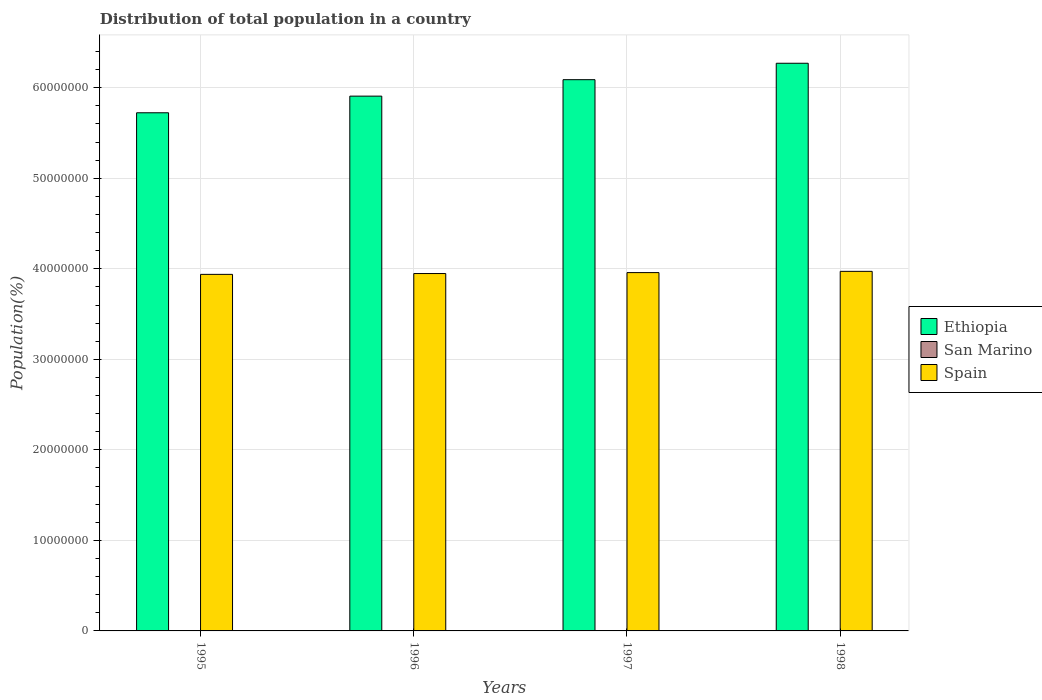How many groups of bars are there?
Your response must be concise. 4. Are the number of bars per tick equal to the number of legend labels?
Offer a very short reply. Yes. Are the number of bars on each tick of the X-axis equal?
Ensure brevity in your answer.  Yes. How many bars are there on the 2nd tick from the right?
Ensure brevity in your answer.  3. What is the label of the 1st group of bars from the left?
Your response must be concise. 1995. In how many cases, is the number of bars for a given year not equal to the number of legend labels?
Offer a terse response. 0. What is the population of in San Marino in 1995?
Provide a succinct answer. 2.59e+04. Across all years, what is the maximum population of in San Marino?
Give a very brief answer. 2.68e+04. Across all years, what is the minimum population of in Ethiopia?
Offer a very short reply. 5.72e+07. In which year was the population of in Spain maximum?
Give a very brief answer. 1998. In which year was the population of in Ethiopia minimum?
Make the answer very short. 1995. What is the total population of in Spain in the graph?
Give a very brief answer. 1.58e+08. What is the difference between the population of in Spain in 1996 and that in 1998?
Your answer should be compact. -2.43e+05. What is the difference between the population of in Spain in 1996 and the population of in San Marino in 1995?
Your answer should be very brief. 3.95e+07. What is the average population of in Spain per year?
Give a very brief answer. 3.95e+07. In the year 1996, what is the difference between the population of in Ethiopia and population of in San Marino?
Your answer should be compact. 5.91e+07. What is the ratio of the population of in San Marino in 1995 to that in 1998?
Offer a terse response. 0.97. Is the population of in Ethiopia in 1995 less than that in 1998?
Give a very brief answer. Yes. Is the difference between the population of in Ethiopia in 1996 and 1998 greater than the difference between the population of in San Marino in 1996 and 1998?
Your answer should be very brief. No. What is the difference between the highest and the second highest population of in San Marino?
Provide a short and direct response. 292. What is the difference between the highest and the lowest population of in Spain?
Your answer should be very brief. 3.34e+05. Is the sum of the population of in Ethiopia in 1995 and 1997 greater than the maximum population of in Spain across all years?
Your answer should be very brief. Yes. What does the 1st bar from the left in 1996 represents?
Give a very brief answer. Ethiopia. What does the 1st bar from the right in 1995 represents?
Provide a succinct answer. Spain. How many bars are there?
Ensure brevity in your answer.  12. What is the difference between two consecutive major ticks on the Y-axis?
Your answer should be very brief. 1.00e+07. Where does the legend appear in the graph?
Your answer should be very brief. Center right. What is the title of the graph?
Your answer should be compact. Distribution of total population in a country. Does "Djibouti" appear as one of the legend labels in the graph?
Your response must be concise. No. What is the label or title of the Y-axis?
Your answer should be very brief. Population(%). What is the Population(%) of Ethiopia in 1995?
Your answer should be compact. 5.72e+07. What is the Population(%) in San Marino in 1995?
Offer a terse response. 2.59e+04. What is the Population(%) of Spain in 1995?
Make the answer very short. 3.94e+07. What is the Population(%) in Ethiopia in 1996?
Your answer should be very brief. 5.91e+07. What is the Population(%) of San Marino in 1996?
Your answer should be very brief. 2.62e+04. What is the Population(%) of Spain in 1996?
Your answer should be very brief. 3.95e+07. What is the Population(%) in Ethiopia in 1997?
Ensure brevity in your answer.  6.09e+07. What is the Population(%) in San Marino in 1997?
Make the answer very short. 2.65e+04. What is the Population(%) of Spain in 1997?
Give a very brief answer. 3.96e+07. What is the Population(%) in Ethiopia in 1998?
Provide a short and direct response. 6.27e+07. What is the Population(%) of San Marino in 1998?
Keep it short and to the point. 2.68e+04. What is the Population(%) of Spain in 1998?
Keep it short and to the point. 3.97e+07. Across all years, what is the maximum Population(%) of Ethiopia?
Your answer should be compact. 6.27e+07. Across all years, what is the maximum Population(%) in San Marino?
Your answer should be very brief. 2.68e+04. Across all years, what is the maximum Population(%) in Spain?
Keep it short and to the point. 3.97e+07. Across all years, what is the minimum Population(%) of Ethiopia?
Provide a short and direct response. 5.72e+07. Across all years, what is the minimum Population(%) of San Marino?
Provide a short and direct response. 2.59e+04. Across all years, what is the minimum Population(%) in Spain?
Give a very brief answer. 3.94e+07. What is the total Population(%) of Ethiopia in the graph?
Provide a succinct answer. 2.40e+08. What is the total Population(%) in San Marino in the graph?
Give a very brief answer. 1.05e+05. What is the total Population(%) of Spain in the graph?
Your response must be concise. 1.58e+08. What is the difference between the Population(%) in Ethiopia in 1995 and that in 1996?
Your answer should be compact. -1.84e+06. What is the difference between the Population(%) of San Marino in 1995 and that in 1996?
Keep it short and to the point. -326. What is the difference between the Population(%) of Spain in 1995 and that in 1996?
Provide a short and direct response. -9.12e+04. What is the difference between the Population(%) in Ethiopia in 1995 and that in 1997?
Provide a succinct answer. -3.66e+06. What is the difference between the Population(%) of San Marino in 1995 and that in 1997?
Offer a terse response. -628. What is the difference between the Population(%) of Spain in 1995 and that in 1997?
Provide a succinct answer. -1.95e+05. What is the difference between the Population(%) of Ethiopia in 1995 and that in 1998?
Your answer should be compact. -5.47e+06. What is the difference between the Population(%) of San Marino in 1995 and that in 1998?
Your response must be concise. -920. What is the difference between the Population(%) of Spain in 1995 and that in 1998?
Give a very brief answer. -3.34e+05. What is the difference between the Population(%) in Ethiopia in 1996 and that in 1997?
Make the answer very short. -1.82e+06. What is the difference between the Population(%) of San Marino in 1996 and that in 1997?
Offer a very short reply. -302. What is the difference between the Population(%) in Spain in 1996 and that in 1997?
Provide a short and direct response. -1.04e+05. What is the difference between the Population(%) of Ethiopia in 1996 and that in 1998?
Your answer should be very brief. -3.63e+06. What is the difference between the Population(%) in San Marino in 1996 and that in 1998?
Provide a short and direct response. -594. What is the difference between the Population(%) in Spain in 1996 and that in 1998?
Provide a succinct answer. -2.43e+05. What is the difference between the Population(%) in Ethiopia in 1997 and that in 1998?
Your answer should be very brief. -1.81e+06. What is the difference between the Population(%) in San Marino in 1997 and that in 1998?
Provide a succinct answer. -292. What is the difference between the Population(%) in Spain in 1997 and that in 1998?
Your response must be concise. -1.39e+05. What is the difference between the Population(%) in Ethiopia in 1995 and the Population(%) in San Marino in 1996?
Ensure brevity in your answer.  5.72e+07. What is the difference between the Population(%) of Ethiopia in 1995 and the Population(%) of Spain in 1996?
Ensure brevity in your answer.  1.78e+07. What is the difference between the Population(%) of San Marino in 1995 and the Population(%) of Spain in 1996?
Your answer should be compact. -3.95e+07. What is the difference between the Population(%) in Ethiopia in 1995 and the Population(%) in San Marino in 1997?
Offer a very short reply. 5.72e+07. What is the difference between the Population(%) in Ethiopia in 1995 and the Population(%) in Spain in 1997?
Make the answer very short. 1.77e+07. What is the difference between the Population(%) of San Marino in 1995 and the Population(%) of Spain in 1997?
Keep it short and to the point. -3.96e+07. What is the difference between the Population(%) in Ethiopia in 1995 and the Population(%) in San Marino in 1998?
Provide a succinct answer. 5.72e+07. What is the difference between the Population(%) of Ethiopia in 1995 and the Population(%) of Spain in 1998?
Provide a short and direct response. 1.75e+07. What is the difference between the Population(%) of San Marino in 1995 and the Population(%) of Spain in 1998?
Offer a very short reply. -3.97e+07. What is the difference between the Population(%) of Ethiopia in 1996 and the Population(%) of San Marino in 1997?
Keep it short and to the point. 5.90e+07. What is the difference between the Population(%) of Ethiopia in 1996 and the Population(%) of Spain in 1997?
Offer a very short reply. 1.95e+07. What is the difference between the Population(%) in San Marino in 1996 and the Population(%) in Spain in 1997?
Keep it short and to the point. -3.96e+07. What is the difference between the Population(%) of Ethiopia in 1996 and the Population(%) of San Marino in 1998?
Your response must be concise. 5.90e+07. What is the difference between the Population(%) in Ethiopia in 1996 and the Population(%) in Spain in 1998?
Provide a succinct answer. 1.94e+07. What is the difference between the Population(%) in San Marino in 1996 and the Population(%) in Spain in 1998?
Your answer should be compact. -3.97e+07. What is the difference between the Population(%) of Ethiopia in 1997 and the Population(%) of San Marino in 1998?
Keep it short and to the point. 6.09e+07. What is the difference between the Population(%) in Ethiopia in 1997 and the Population(%) in Spain in 1998?
Make the answer very short. 2.12e+07. What is the difference between the Population(%) of San Marino in 1997 and the Population(%) of Spain in 1998?
Offer a very short reply. -3.97e+07. What is the average Population(%) of Ethiopia per year?
Give a very brief answer. 6.00e+07. What is the average Population(%) of San Marino per year?
Provide a succinct answer. 2.63e+04. What is the average Population(%) of Spain per year?
Your answer should be very brief. 3.95e+07. In the year 1995, what is the difference between the Population(%) in Ethiopia and Population(%) in San Marino?
Offer a terse response. 5.72e+07. In the year 1995, what is the difference between the Population(%) of Ethiopia and Population(%) of Spain?
Provide a short and direct response. 1.79e+07. In the year 1995, what is the difference between the Population(%) in San Marino and Population(%) in Spain?
Offer a very short reply. -3.94e+07. In the year 1996, what is the difference between the Population(%) of Ethiopia and Population(%) of San Marino?
Provide a short and direct response. 5.91e+07. In the year 1996, what is the difference between the Population(%) in Ethiopia and Population(%) in Spain?
Your response must be concise. 1.96e+07. In the year 1996, what is the difference between the Population(%) of San Marino and Population(%) of Spain?
Ensure brevity in your answer.  -3.95e+07. In the year 1997, what is the difference between the Population(%) in Ethiopia and Population(%) in San Marino?
Keep it short and to the point. 6.09e+07. In the year 1997, what is the difference between the Population(%) of Ethiopia and Population(%) of Spain?
Offer a very short reply. 2.13e+07. In the year 1997, what is the difference between the Population(%) in San Marino and Population(%) in Spain?
Give a very brief answer. -3.96e+07. In the year 1998, what is the difference between the Population(%) in Ethiopia and Population(%) in San Marino?
Provide a succinct answer. 6.27e+07. In the year 1998, what is the difference between the Population(%) of Ethiopia and Population(%) of Spain?
Your response must be concise. 2.30e+07. In the year 1998, what is the difference between the Population(%) of San Marino and Population(%) of Spain?
Provide a short and direct response. -3.97e+07. What is the ratio of the Population(%) of Ethiopia in 1995 to that in 1996?
Your answer should be compact. 0.97. What is the ratio of the Population(%) of San Marino in 1995 to that in 1996?
Your answer should be compact. 0.99. What is the ratio of the Population(%) in Spain in 1995 to that in 1996?
Provide a short and direct response. 1. What is the ratio of the Population(%) in Ethiopia in 1995 to that in 1997?
Provide a succinct answer. 0.94. What is the ratio of the Population(%) in San Marino in 1995 to that in 1997?
Make the answer very short. 0.98. What is the ratio of the Population(%) of Spain in 1995 to that in 1997?
Your answer should be very brief. 1. What is the ratio of the Population(%) in Ethiopia in 1995 to that in 1998?
Your answer should be very brief. 0.91. What is the ratio of the Population(%) in San Marino in 1995 to that in 1998?
Ensure brevity in your answer.  0.97. What is the ratio of the Population(%) of Ethiopia in 1996 to that in 1997?
Ensure brevity in your answer.  0.97. What is the ratio of the Population(%) of San Marino in 1996 to that in 1997?
Your answer should be compact. 0.99. What is the ratio of the Population(%) in Ethiopia in 1996 to that in 1998?
Provide a succinct answer. 0.94. What is the ratio of the Population(%) in San Marino in 1996 to that in 1998?
Provide a succinct answer. 0.98. What is the ratio of the Population(%) in Ethiopia in 1997 to that in 1998?
Your answer should be compact. 0.97. What is the ratio of the Population(%) in San Marino in 1997 to that in 1998?
Provide a succinct answer. 0.99. What is the ratio of the Population(%) of Spain in 1997 to that in 1998?
Offer a very short reply. 1. What is the difference between the highest and the second highest Population(%) in Ethiopia?
Provide a succinct answer. 1.81e+06. What is the difference between the highest and the second highest Population(%) of San Marino?
Your answer should be compact. 292. What is the difference between the highest and the second highest Population(%) of Spain?
Ensure brevity in your answer.  1.39e+05. What is the difference between the highest and the lowest Population(%) in Ethiopia?
Your answer should be compact. 5.47e+06. What is the difference between the highest and the lowest Population(%) of San Marino?
Your response must be concise. 920. What is the difference between the highest and the lowest Population(%) of Spain?
Offer a very short reply. 3.34e+05. 